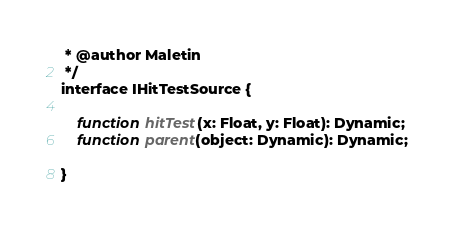<code> <loc_0><loc_0><loc_500><loc_500><_Haxe_> * @author Maletin
 */
interface IHitTestSource {

	function hitTest(x: Float, y: Float): Dynamic;
	function parent(object: Dynamic): Dynamic;

}</code> 